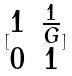Convert formula to latex. <formula><loc_0><loc_0><loc_500><loc_500>[ \begin{matrix} 1 & \frac { 1 } { G } \\ 0 & 1 \end{matrix} ]</formula> 